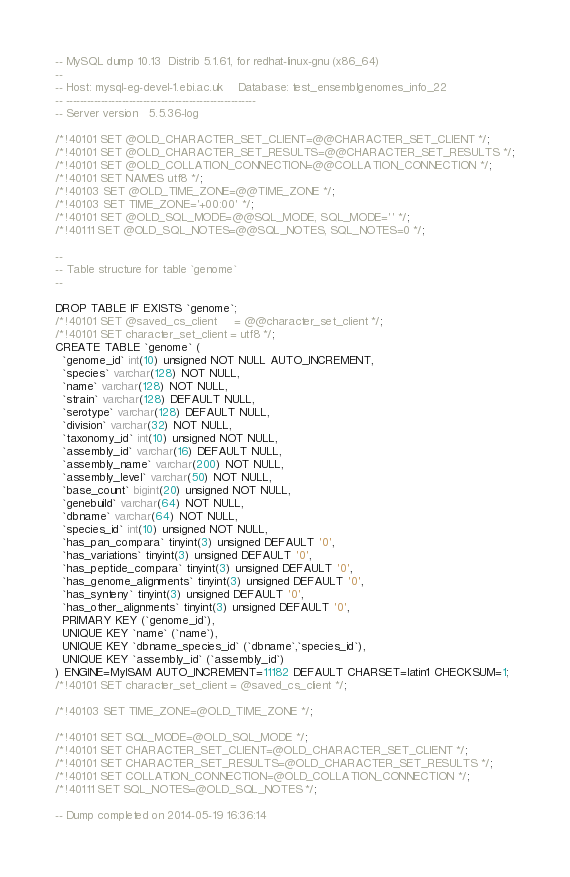Convert code to text. <code><loc_0><loc_0><loc_500><loc_500><_SQL_>-- MySQL dump 10.13  Distrib 5.1.61, for redhat-linux-gnu (x86_64)
--
-- Host: mysql-eg-devel-1.ebi.ac.uk    Database: test_ensemblgenomes_info_22
-- ------------------------------------------------------
-- Server version	5.5.36-log

/*!40101 SET @OLD_CHARACTER_SET_CLIENT=@@CHARACTER_SET_CLIENT */;
/*!40101 SET @OLD_CHARACTER_SET_RESULTS=@@CHARACTER_SET_RESULTS */;
/*!40101 SET @OLD_COLLATION_CONNECTION=@@COLLATION_CONNECTION */;
/*!40101 SET NAMES utf8 */;
/*!40103 SET @OLD_TIME_ZONE=@@TIME_ZONE */;
/*!40103 SET TIME_ZONE='+00:00' */;
/*!40101 SET @OLD_SQL_MODE=@@SQL_MODE, SQL_MODE='' */;
/*!40111 SET @OLD_SQL_NOTES=@@SQL_NOTES, SQL_NOTES=0 */;

--
-- Table structure for table `genome`
--

DROP TABLE IF EXISTS `genome`;
/*!40101 SET @saved_cs_client     = @@character_set_client */;
/*!40101 SET character_set_client = utf8 */;
CREATE TABLE `genome` (
  `genome_id` int(10) unsigned NOT NULL AUTO_INCREMENT,
  `species` varchar(128) NOT NULL,
  `name` varchar(128) NOT NULL,
  `strain` varchar(128) DEFAULT NULL,
  `serotype` varchar(128) DEFAULT NULL,
  `division` varchar(32) NOT NULL,
  `taxonomy_id` int(10) unsigned NOT NULL,
  `assembly_id` varchar(16) DEFAULT NULL,
  `assembly_name` varchar(200) NOT NULL,
  `assembly_level` varchar(50) NOT NULL,
  `base_count` bigint(20) unsigned NOT NULL,
  `genebuild` varchar(64) NOT NULL,
  `dbname` varchar(64) NOT NULL,
  `species_id` int(10) unsigned NOT NULL,
  `has_pan_compara` tinyint(3) unsigned DEFAULT '0',
  `has_variations` tinyint(3) unsigned DEFAULT '0',
  `has_peptide_compara` tinyint(3) unsigned DEFAULT '0',
  `has_genome_alignments` tinyint(3) unsigned DEFAULT '0',
  `has_synteny` tinyint(3) unsigned DEFAULT '0',
  `has_other_alignments` tinyint(3) unsigned DEFAULT '0',
  PRIMARY KEY (`genome_id`),
  UNIQUE KEY `name` (`name`),
  UNIQUE KEY `dbname_species_id` (`dbname`,`species_id`),
  UNIQUE KEY `assembly_id` (`assembly_id`)
) ENGINE=MyISAM AUTO_INCREMENT=11182 DEFAULT CHARSET=latin1 CHECKSUM=1;
/*!40101 SET character_set_client = @saved_cs_client */;

/*!40103 SET TIME_ZONE=@OLD_TIME_ZONE */;

/*!40101 SET SQL_MODE=@OLD_SQL_MODE */;
/*!40101 SET CHARACTER_SET_CLIENT=@OLD_CHARACTER_SET_CLIENT */;
/*!40101 SET CHARACTER_SET_RESULTS=@OLD_CHARACTER_SET_RESULTS */;
/*!40101 SET COLLATION_CONNECTION=@OLD_COLLATION_CONNECTION */;
/*!40111 SET SQL_NOTES=@OLD_SQL_NOTES */;

-- Dump completed on 2014-05-19 16:36:14
</code> 